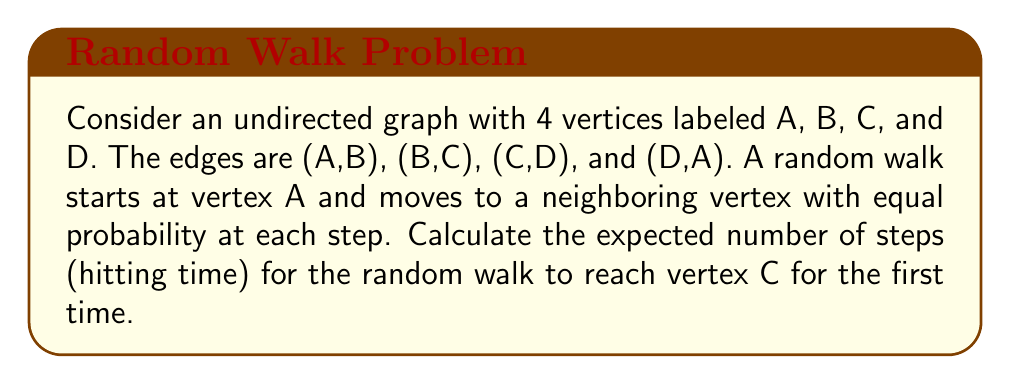Can you answer this question? Let's approach this step-by-step:

1) First, let's define our state space. We have 4 states: A, B, C, and D.

2) We need to set up a system of equations for the expected hitting times. Let $h_X$ be the expected hitting time to C starting from vertex X.

3) For vertex C, we have $h_C = 0$ since we're already at the target.

4) For the other vertices, we can set up equations based on the one-step analysis:

   $h_A = 1 + \frac{1}{2}h_B + \frac{1}{2}h_D$
   $h_B = 1 + \frac{1}{2}h_A + \frac{1}{2}h_C = 1 + \frac{1}{2}h_A$
   $h_D = 1 + \frac{1}{2}h_A + \frac{1}{2}h_C = 1 + \frac{1}{2}h_A$

5) From the last two equations, we can see that $h_B = h_D$. Let's call this value $h$.

6) Substituting into the equation for $h_A$:

   $h_A = 1 + h$

7) And for $h$:

   $h = 1 + \frac{1}{2}h_A = 1 + \frac{1}{2}(1 + h) = 1 + \frac{1}{2} + \frac{1}{2}h$

8) Solving for $h$:

   $\frac{1}{2}h = \frac{3}{2}$
   $h = 3$

9) Therefore, $h_A = 1 + h = 4$

Thus, starting from vertex A, the expected hitting time to reach vertex C is 4 steps.
Answer: 4 steps 